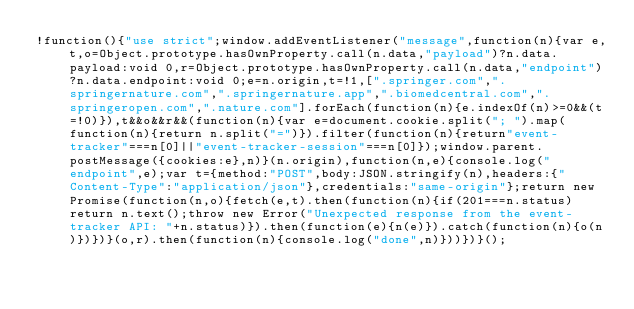<code> <loc_0><loc_0><loc_500><loc_500><_JavaScript_>!function(){"use strict";window.addEventListener("message",function(n){var e,t,o=Object.prototype.hasOwnProperty.call(n.data,"payload")?n.data.payload:void 0,r=Object.prototype.hasOwnProperty.call(n.data,"endpoint")?n.data.endpoint:void 0;e=n.origin,t=!1,[".springer.com",".springernature.com",".springernature.app",".biomedcentral.com",".springeropen.com",".nature.com"].forEach(function(n){e.indexOf(n)>=0&&(t=!0)}),t&&o&&r&&(function(n){var e=document.cookie.split("; ").map(function(n){return n.split("=")}).filter(function(n){return"event-tracker"===n[0]||"event-tracker-session"===n[0]});window.parent.postMessage({cookies:e},n)}(n.origin),function(n,e){console.log("endpoint",e);var t={method:"POST",body:JSON.stringify(n),headers:{"Content-Type":"application/json"},credentials:"same-origin"};return new Promise(function(n,o){fetch(e,t).then(function(n){if(201===n.status)return n.text();throw new Error("Unexpected response from the event-tracker API: "+n.status)}).then(function(e){n(e)}).catch(function(n){o(n)})})}(o,r).then(function(n){console.log("done",n)}))})}();
</code> 